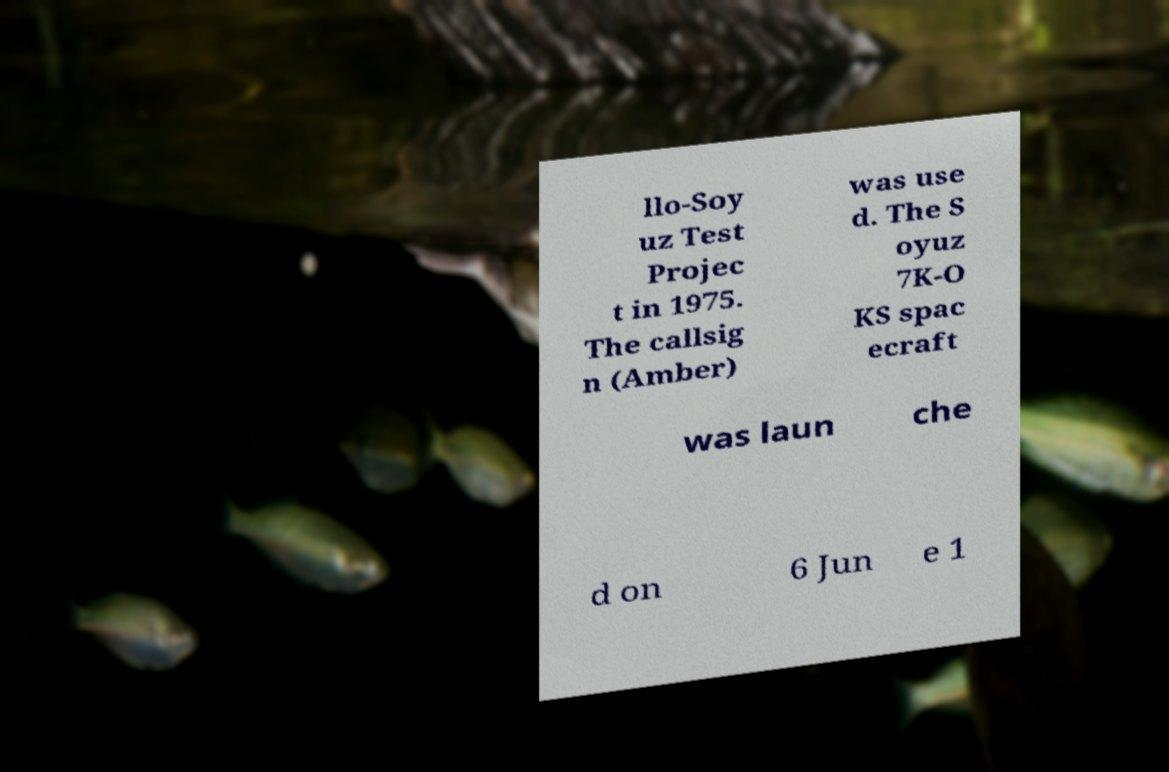Could you extract and type out the text from this image? llo-Soy uz Test Projec t in 1975. The callsig n (Amber) was use d. The S oyuz 7K-O KS spac ecraft was laun che d on 6 Jun e 1 